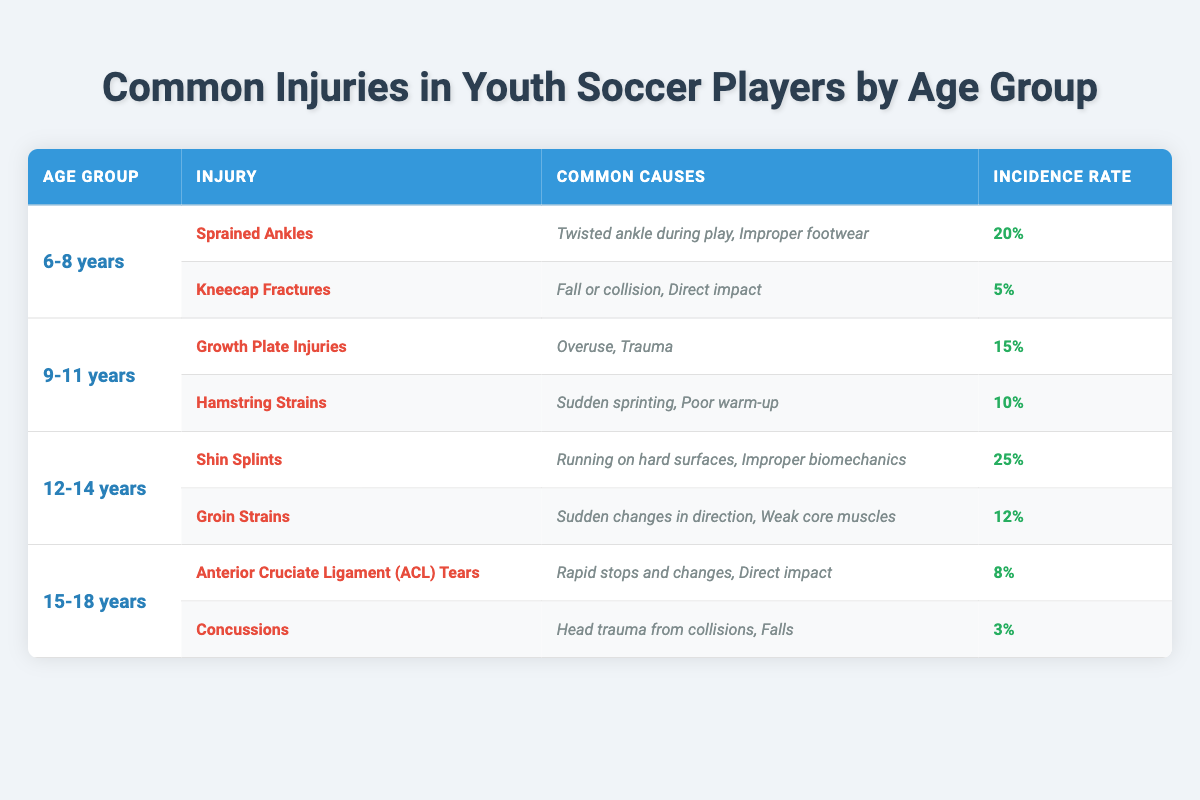What is the most common injury for 6-8 year olds? The table shows that the injury with the highest incidence rate for the 6-8 age group is "Sprained Ankles" at 20%.
Answer: Sprained Ankles How many injuries are listed for the age group 15-18 years? There are two injuries listed for the 15-18 age group: "Anterior Cruciate Ligament (ACL) Tears" and "Concussions".
Answer: 2 Which age group has the highest incidence rate of injuries? To determine which group has the highest incidence rate, we look at the rates: 20% (6-8), 15% (9-11), 25% (12-14), and 8% (15-18). The highest is 25% from the 12-14 age group.
Answer: 12-14 years Is "Hamstring Strains" more common than "Kneecap Fractures"? "Hamstring Strains" has an incidence rate of 10% while "Kneecap Fractures" has a rate of 5%. Since 10% is greater than 5%, the statement is true.
Answer: Yes What are the common causes for Shin Splints in the 12-14 age group? The common causes listed for "Shin Splints" are "Running on hard surfaces" and "Improper biomechanics".
Answer: Running on hard surfaces, Improper biomechanics Which injury has the lowest incidence rate in the table? "Concussions" has the lowest incidence rate at 3%. We compare all listed rates and find this is the smallest.
Answer: Concussions How much greater is the incidence rate of Shin Splints compared to Groin Strains? The incidence rate of Shin Splints is 25% and that of Groin Strains is 12%. We subtract 12% from 25%, which gives us 13%.
Answer: 13% Does the 9-11 age group have more serious injuries compared to the 6-8 age group? The injuries listed for the 9-11 age group are "Growth Plate Injuries" and "Hamstring Strains" with rates of 15% and 10%, respectively. The 6-8 age group has "Sprained Ankles" and "Kneecap Fractures" with lower rates. Thus, we conclude the injuries in the 9-11 age group are more serious as indicated by higher rates.
Answer: Yes What is the total incidence rate for the 12-14 age group injuries? The incidence rates for the 12-14 group are 25% and 12%. Adding these gives us 25% + 12% = 37%.
Answer: 37% Which injury in the 15-18 years age group is associated with head trauma? The injury associated with head trauma is "Concussions". This is directly stated in the common causes for that injury in the table.
Answer: Concussions Is there any age group that has a higher incidence rate of injuries than 20%? Yes, the 12-14 age group has an incidence rate of 25%, which is higher than 20%. By reviewing the rates, we confirm this finding.
Answer: Yes 